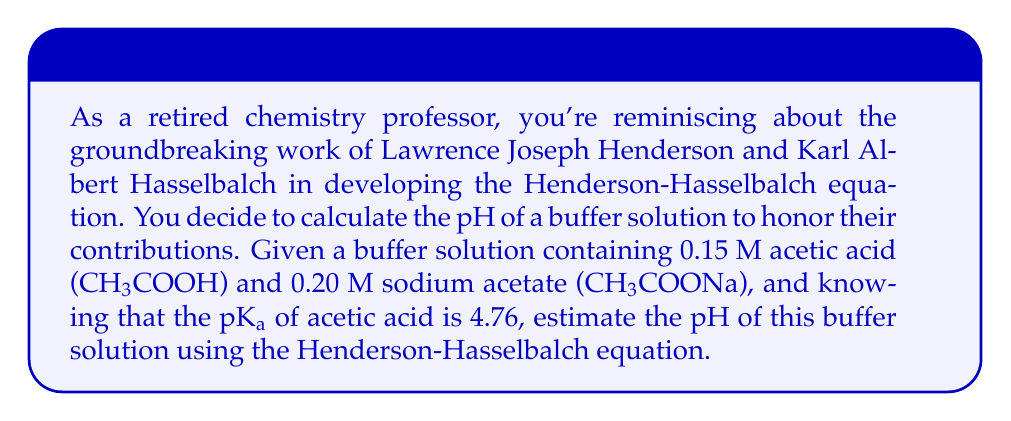Give your solution to this math problem. To solve this problem, we'll use the Henderson-Hasselbalch equation:

$$ pH = pK_a + \log\left(\frac{[A^-]}{[HA]}\right) $$

Where:
- $pH$ is the pH of the buffer solution
- $pK_a$ is the negative logarithm of the acid dissociation constant
- $[A^-]$ is the concentration of the conjugate base (acetate ion)
- $[HA]$ is the concentration of the weak acid (acetic acid)

Given:
- $pK_a$ of acetic acid = 4.76
- $[HA]$ (acetic acid) = 0.15 M
- $[A^-]$ (acetate ion from sodium acetate) = 0.20 M

Let's substitute these values into the Henderson-Hasselbalch equation:

$$ pH = 4.76 + \log\left(\frac{0.20}{0.15}\right) $$

Now, let's solve this step-by-step:

1) First, calculate the ratio inside the logarithm:
   $\frac{0.20}{0.15} = 1.3333$

2) Take the logarithm of this ratio:
   $\log(1.3333) = 0.1249$

3) Add this to the $pK_a$:
   $4.76 + 0.1249 = 4.8849$

Therefore, the estimated pH of the buffer solution is approximately 4.88.
Answer: The estimated pH of the buffer solution is 4.88. 